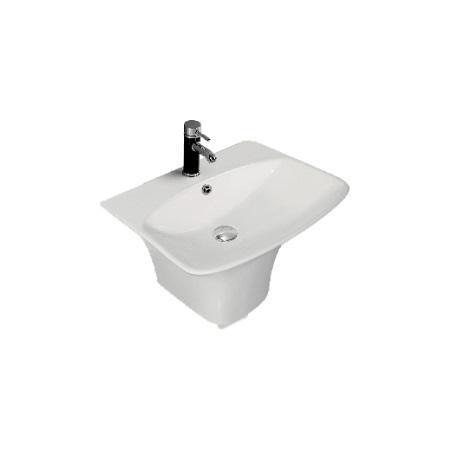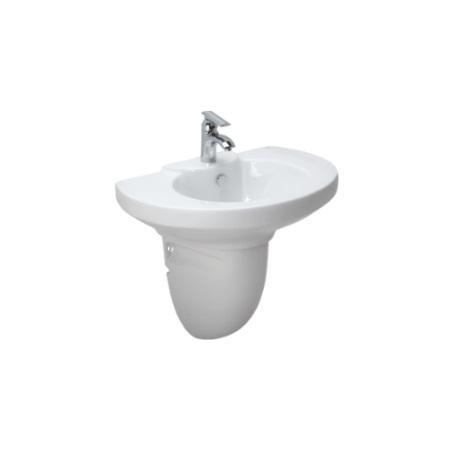The first image is the image on the left, the second image is the image on the right. Analyze the images presented: Is the assertion "The right-hand sink is rectangular rather than rounded." valid? Answer yes or no. No. 